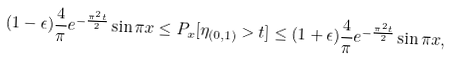Convert formula to latex. <formula><loc_0><loc_0><loc_500><loc_500>( 1 - \epsilon ) \frac { 4 } { \pi } e ^ { - \frac { \pi ^ { 2 } t } { 2 } } \sin \pi x \leq P _ { x } [ \eta _ { ( 0 , 1 ) } > t ] \leq ( 1 + \epsilon ) \frac { 4 } { \pi } e ^ { - \frac { \pi ^ { 2 } t } { 2 } } \sin \pi x ,</formula> 